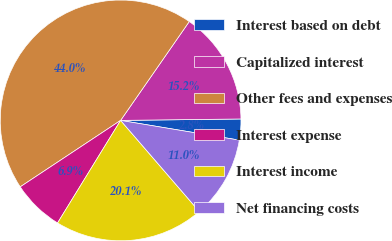Convert chart. <chart><loc_0><loc_0><loc_500><loc_500><pie_chart><fcel>Interest based on debt<fcel>Capitalized interest<fcel>Other fees and expenses<fcel>Interest expense<fcel>Interest income<fcel>Net financing costs<nl><fcel>2.81%<fcel>15.15%<fcel>43.97%<fcel>6.92%<fcel>20.11%<fcel>11.04%<nl></chart> 